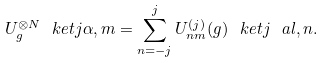Convert formula to latex. <formula><loc_0><loc_0><loc_500><loc_500>U _ { g } ^ { \otimes N } \ k e t { j \alpha , m } = \sum _ { n = - j } ^ { j } U _ { n m } ^ { ( j ) } ( g ) \ k e t { j \ a l , n } .</formula> 